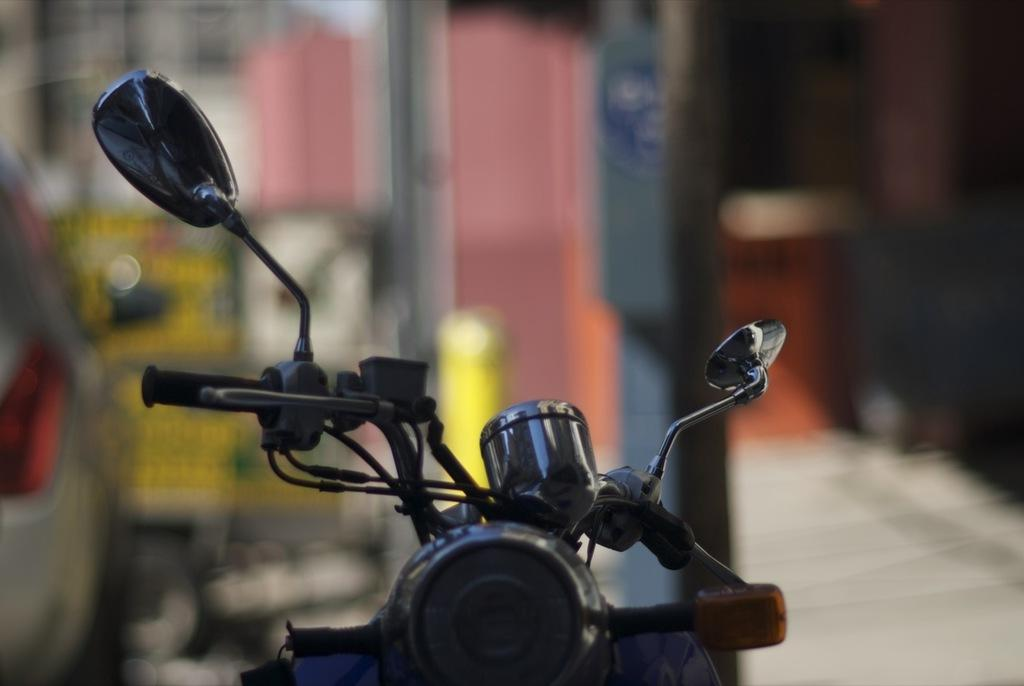What is the main object in the image? There is a bike in the image. What part of the bike can be seen? The front part of the bike is visible. What features are present on the bike? The bike has handles, mirrors, and a headlight. How would you describe the background of the image? The background of the image is blurred. How many zephyrs are present in the image? There are no zephyrs present in the image, as a zephyr is a gentle breeze and not a visible object. Are the bike's brothers also visible in the image? There is no mention of brothers or any other bikes in the image, so we cannot answer this question. 